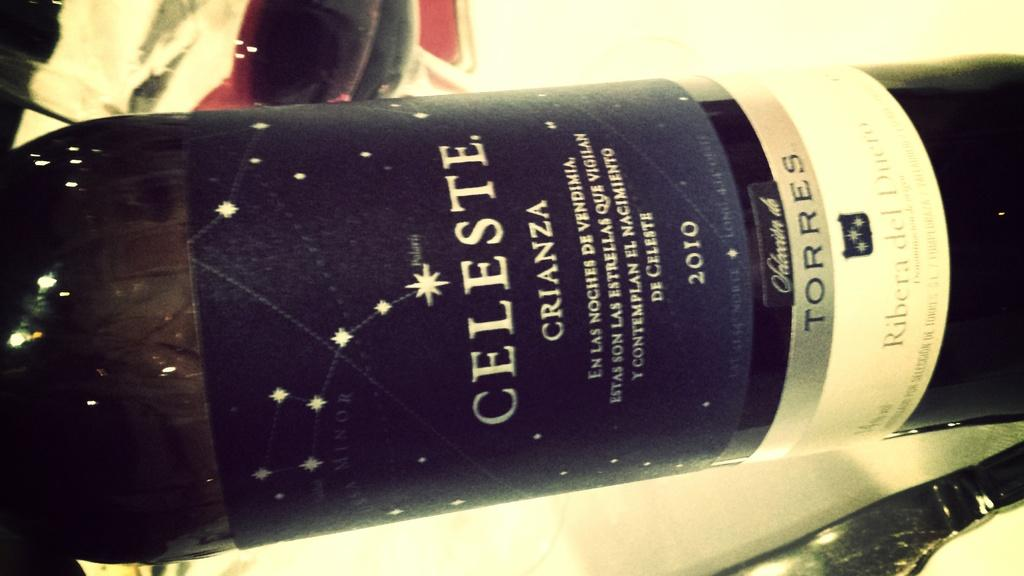Provide a one-sentence caption for the provided image. A bottle with a blue label by Celeste. 